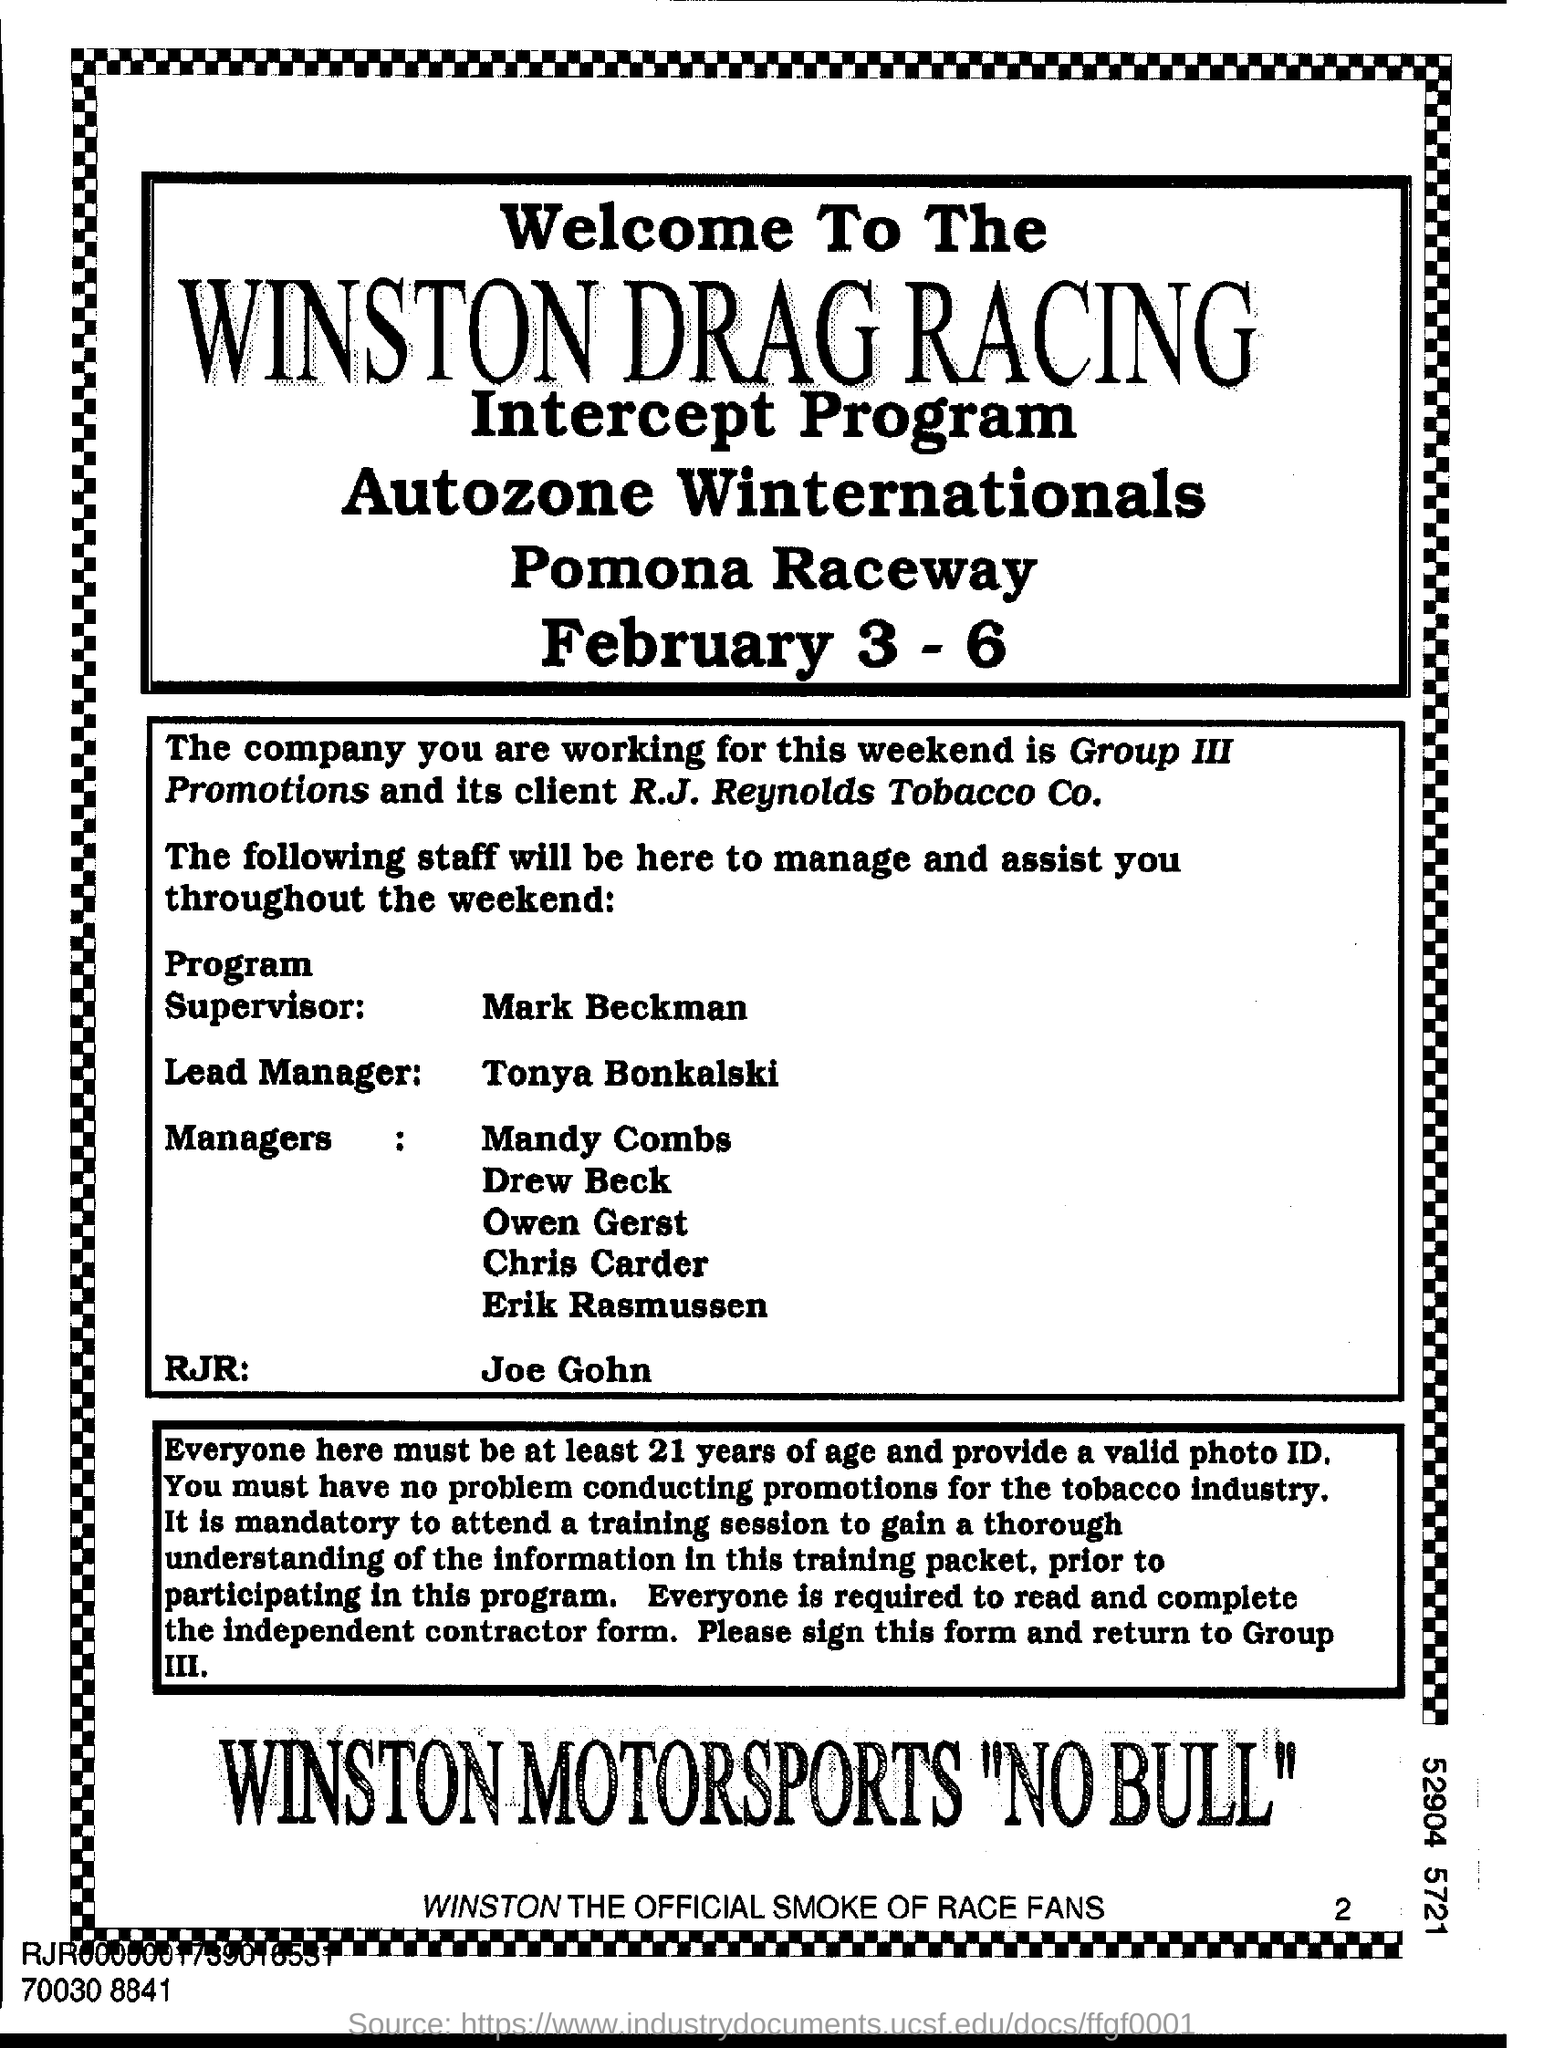What is the flyer about?
Give a very brief answer. Winston Drag Racing Intercept Program. Who is the program supervisor for the intercept program?
Give a very brief answer. Mark Beckman. When is the Intercept program scheduled?
Your answer should be very brief. February 3 - 6. Who is the client of Group III Promotions?
Provide a succinct answer. R.J. Reynolds Tobacco Co. Who is the program supervisor?
Provide a short and direct response. Mark Beckman. Who is the lead manager?
Ensure brevity in your answer.  Tonya Bonkalski. 